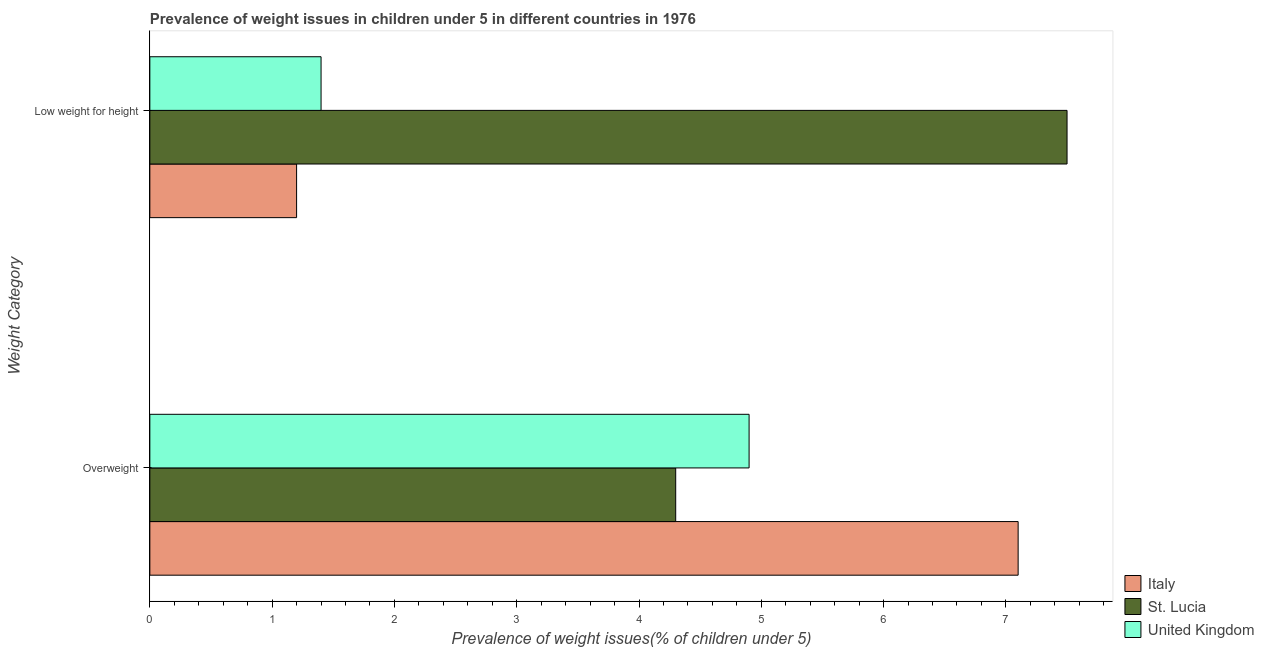How many groups of bars are there?
Ensure brevity in your answer.  2. Are the number of bars on each tick of the Y-axis equal?
Give a very brief answer. Yes. How many bars are there on the 1st tick from the bottom?
Make the answer very short. 3. What is the label of the 1st group of bars from the top?
Offer a terse response. Low weight for height. What is the percentage of underweight children in United Kingdom?
Your answer should be very brief. 1.4. Across all countries, what is the maximum percentage of overweight children?
Provide a succinct answer. 7.1. Across all countries, what is the minimum percentage of overweight children?
Make the answer very short. 4.3. What is the total percentage of overweight children in the graph?
Offer a very short reply. 16.3. What is the difference between the percentage of underweight children in United Kingdom and that in Italy?
Provide a short and direct response. 0.2. What is the difference between the percentage of overweight children in St. Lucia and the percentage of underweight children in United Kingdom?
Give a very brief answer. 2.9. What is the average percentage of underweight children per country?
Keep it short and to the point. 3.37. What is the difference between the percentage of overweight children and percentage of underweight children in St. Lucia?
Your response must be concise. -3.2. What is the ratio of the percentage of underweight children in United Kingdom to that in Italy?
Provide a succinct answer. 1.17. What does the 1st bar from the top in Overweight represents?
Provide a succinct answer. United Kingdom. What does the 1st bar from the bottom in Low weight for height represents?
Keep it short and to the point. Italy. Are all the bars in the graph horizontal?
Make the answer very short. Yes. How many countries are there in the graph?
Provide a succinct answer. 3. Are the values on the major ticks of X-axis written in scientific E-notation?
Provide a succinct answer. No. Does the graph contain any zero values?
Ensure brevity in your answer.  No. Does the graph contain grids?
Keep it short and to the point. No. What is the title of the graph?
Provide a short and direct response. Prevalence of weight issues in children under 5 in different countries in 1976. What is the label or title of the X-axis?
Give a very brief answer. Prevalence of weight issues(% of children under 5). What is the label or title of the Y-axis?
Make the answer very short. Weight Category. What is the Prevalence of weight issues(% of children under 5) of Italy in Overweight?
Offer a terse response. 7.1. What is the Prevalence of weight issues(% of children under 5) in St. Lucia in Overweight?
Keep it short and to the point. 4.3. What is the Prevalence of weight issues(% of children under 5) of United Kingdom in Overweight?
Offer a very short reply. 4.9. What is the Prevalence of weight issues(% of children under 5) in Italy in Low weight for height?
Ensure brevity in your answer.  1.2. What is the Prevalence of weight issues(% of children under 5) in United Kingdom in Low weight for height?
Ensure brevity in your answer.  1.4. Across all Weight Category, what is the maximum Prevalence of weight issues(% of children under 5) in Italy?
Offer a terse response. 7.1. Across all Weight Category, what is the maximum Prevalence of weight issues(% of children under 5) of St. Lucia?
Make the answer very short. 7.5. Across all Weight Category, what is the maximum Prevalence of weight issues(% of children under 5) in United Kingdom?
Keep it short and to the point. 4.9. Across all Weight Category, what is the minimum Prevalence of weight issues(% of children under 5) in Italy?
Ensure brevity in your answer.  1.2. Across all Weight Category, what is the minimum Prevalence of weight issues(% of children under 5) in St. Lucia?
Offer a terse response. 4.3. Across all Weight Category, what is the minimum Prevalence of weight issues(% of children under 5) in United Kingdom?
Your response must be concise. 1.4. What is the difference between the Prevalence of weight issues(% of children under 5) of St. Lucia in Overweight and that in Low weight for height?
Provide a short and direct response. -3.2. What is the difference between the Prevalence of weight issues(% of children under 5) in United Kingdom in Overweight and that in Low weight for height?
Make the answer very short. 3.5. What is the difference between the Prevalence of weight issues(% of children under 5) in Italy in Overweight and the Prevalence of weight issues(% of children under 5) in St. Lucia in Low weight for height?
Provide a short and direct response. -0.4. What is the difference between the Prevalence of weight issues(% of children under 5) of Italy in Overweight and the Prevalence of weight issues(% of children under 5) of United Kingdom in Low weight for height?
Offer a terse response. 5.7. What is the difference between the Prevalence of weight issues(% of children under 5) of St. Lucia in Overweight and the Prevalence of weight issues(% of children under 5) of United Kingdom in Low weight for height?
Keep it short and to the point. 2.9. What is the average Prevalence of weight issues(% of children under 5) of Italy per Weight Category?
Your response must be concise. 4.15. What is the average Prevalence of weight issues(% of children under 5) in United Kingdom per Weight Category?
Offer a very short reply. 3.15. What is the difference between the Prevalence of weight issues(% of children under 5) of Italy and Prevalence of weight issues(% of children under 5) of St. Lucia in Overweight?
Your answer should be very brief. 2.8. What is the difference between the Prevalence of weight issues(% of children under 5) in Italy and Prevalence of weight issues(% of children under 5) in St. Lucia in Low weight for height?
Offer a terse response. -6.3. What is the difference between the Prevalence of weight issues(% of children under 5) of St. Lucia and Prevalence of weight issues(% of children under 5) of United Kingdom in Low weight for height?
Give a very brief answer. 6.1. What is the ratio of the Prevalence of weight issues(% of children under 5) in Italy in Overweight to that in Low weight for height?
Your answer should be very brief. 5.92. What is the ratio of the Prevalence of weight issues(% of children under 5) in St. Lucia in Overweight to that in Low weight for height?
Make the answer very short. 0.57. What is the difference between the highest and the second highest Prevalence of weight issues(% of children under 5) of Italy?
Keep it short and to the point. 5.9. What is the difference between the highest and the second highest Prevalence of weight issues(% of children under 5) in St. Lucia?
Keep it short and to the point. 3.2. What is the difference between the highest and the lowest Prevalence of weight issues(% of children under 5) in United Kingdom?
Provide a short and direct response. 3.5. 